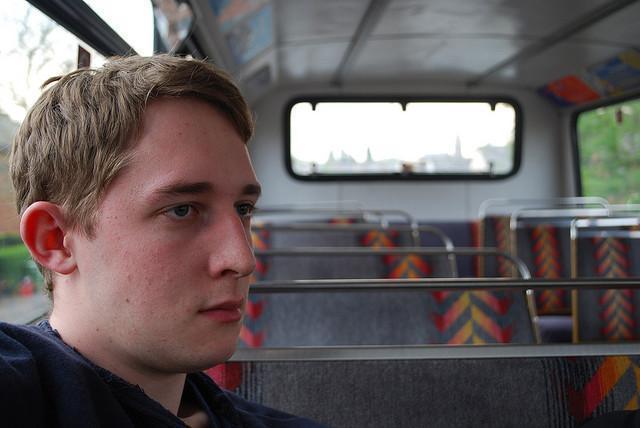Is the statement "The person is at the left side of the bus." accurate regarding the image?
Answer yes or no. Yes. 